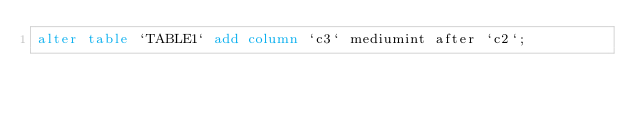Convert code to text. <code><loc_0><loc_0><loc_500><loc_500><_SQL_>alter table `TABLE1` add column `c3` mediumint after `c2`;</code> 